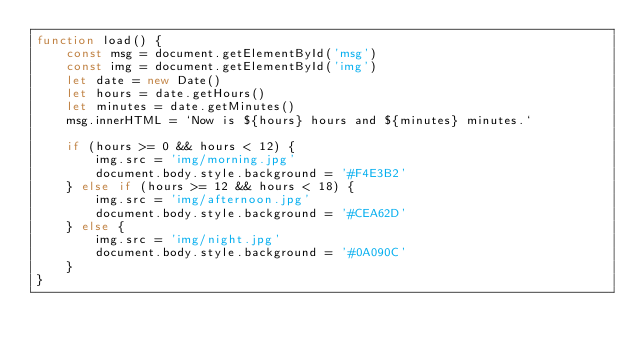<code> <loc_0><loc_0><loc_500><loc_500><_JavaScript_>function load() {
    const msg = document.getElementById('msg')
    const img = document.getElementById('img')
    let date = new Date()
    let hours = date.getHours()
    let minutes = date.getMinutes()
    msg.innerHTML = `Now is ${hours} hours and ${minutes} minutes.`

    if (hours >= 0 && hours < 12) {
        img.src = 'img/morning.jpg'
        document.body.style.background = '#F4E3B2'
    } else if (hours >= 12 && hours < 18) {
        img.src = 'img/afternoon.jpg'
        document.body.style.background = '#CEA62D'
    } else {
        img.src = 'img/night.jpg'
        document.body.style.background = '#0A090C'
    }
}</code> 